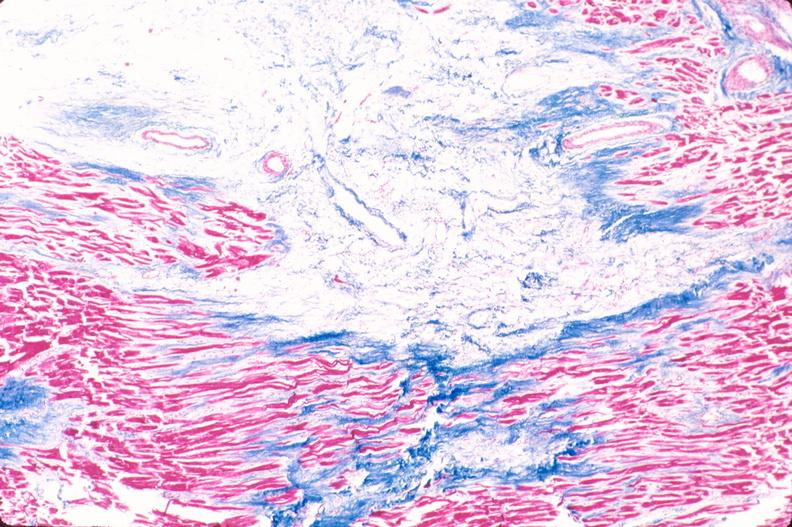how does this image show heart, old myocardial infarction?
Answer the question using a single word or phrase. With fibrosis trichrome 